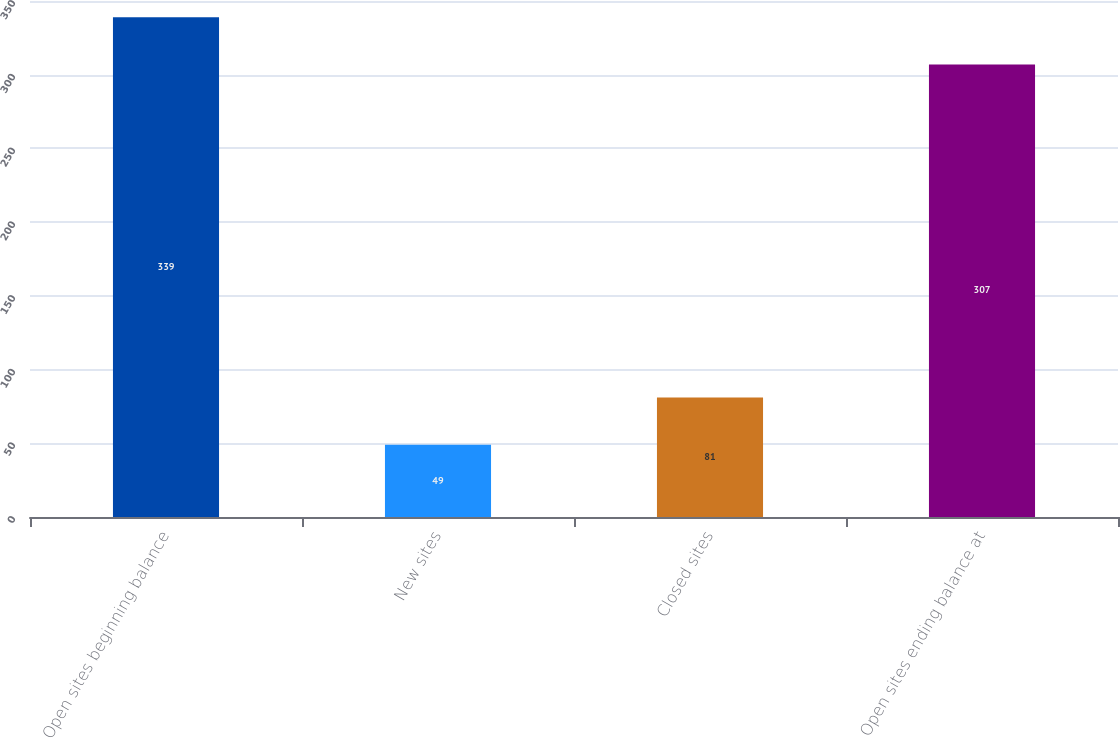Convert chart to OTSL. <chart><loc_0><loc_0><loc_500><loc_500><bar_chart><fcel>Open sites beginning balance<fcel>New sites<fcel>Closed sites<fcel>Open sites ending balance at<nl><fcel>339<fcel>49<fcel>81<fcel>307<nl></chart> 